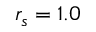Convert formula to latex. <formula><loc_0><loc_0><loc_500><loc_500>r _ { s } = 1 . 0</formula> 